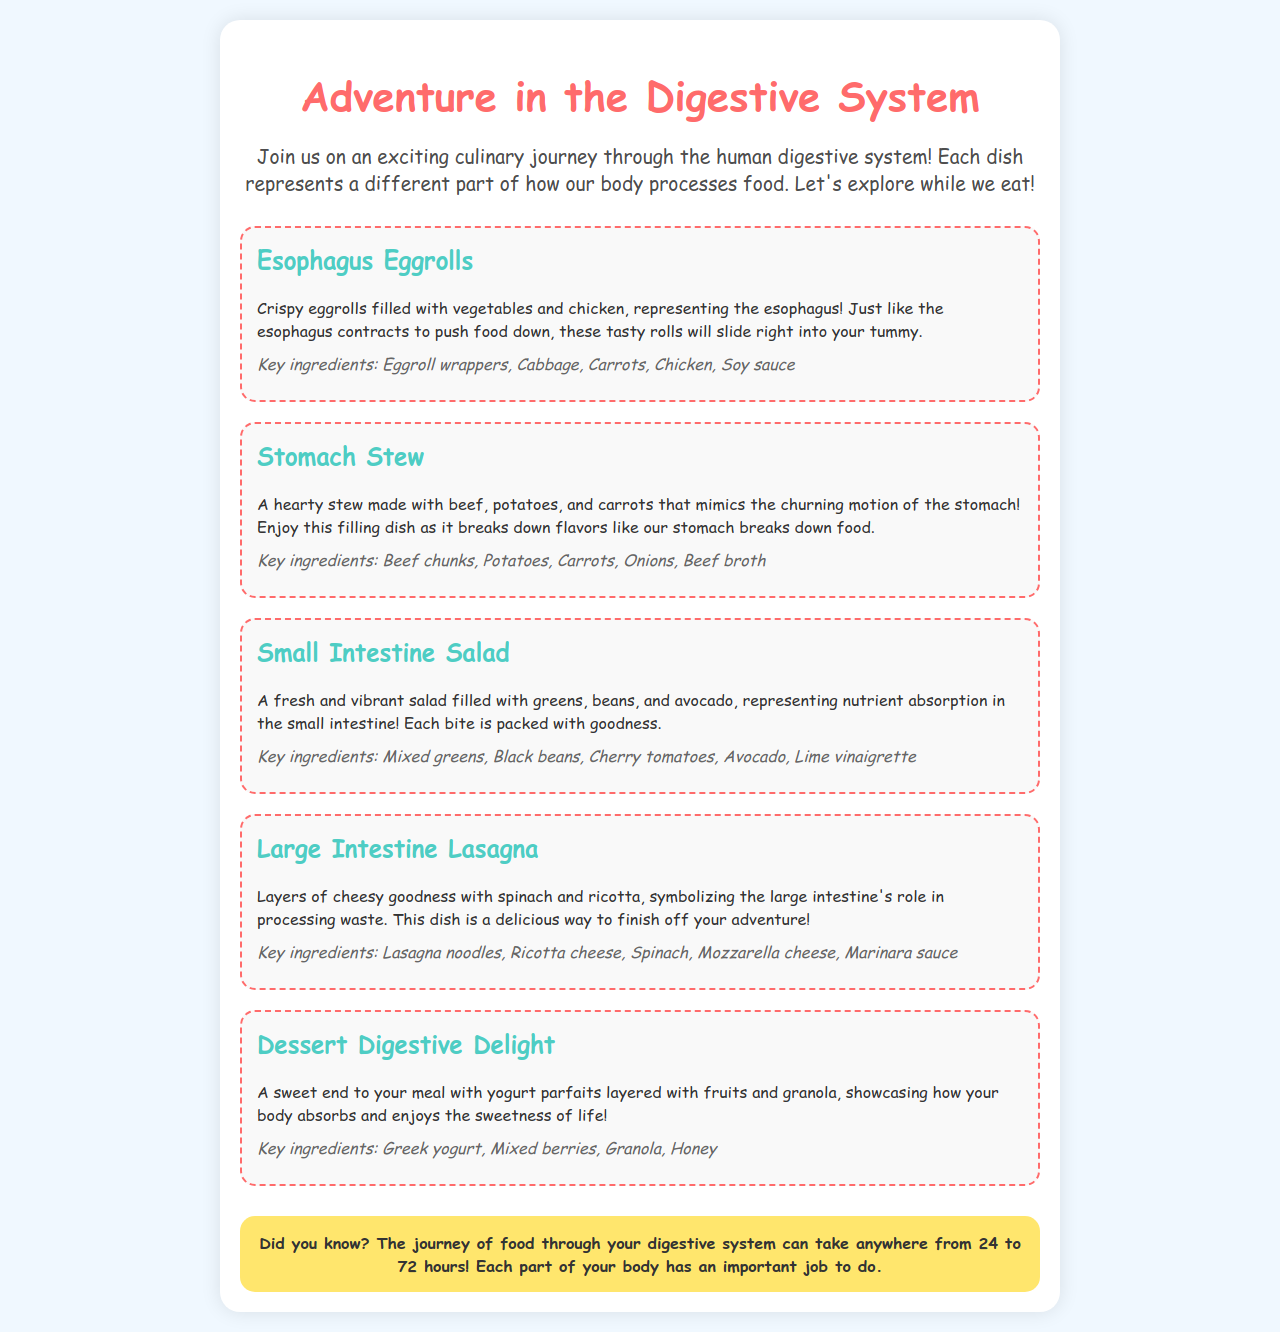What is the name of the dish that represents the esophagus? The dish representing the esophagus is referred to as "Esophagus Eggrolls."
Answer: Esophagus Eggrolls What are the key ingredients of the Stomach Stew? The key ingredients listed for the Stomach Stew include beef chunks, potatoes, carrots, onions, and beef broth.
Answer: Beef chunks, potatoes, carrots, onions, beef broth What dish mimics the nutrient absorption process? The dish that represents nutrient absorption is "Small Intestine Salad."
Answer: Small Intestine Salad How many hours does the journey of food through the digestive system take? The document states that the journey of food through the digestive system can take anywhere from 24 to 72 hours.
Answer: 24 to 72 hours Which dish symbolizes the large intestine's role in processing waste? The dish that symbolizes the role of the large intestine is "Large Intestine Lasagna."
Answer: Large Intestine Lasagna What type of dessert is featured in the menu? The dessert featured in the menu is a yogurt parfait layered with fruits and granola.
Answer: Yogurt parfait What is the color of the title text for the menu? The title text is colored in a shade referred to as "ff6b6b."
Answer: ff6b6b What is the main function represented by the Stomach Stew? The main function represented by the Stomach Stew is the churning motion of the stomach.
Answer: Churning motion of the stomach What type of salad is included in the lunch option? The type of salad included is a fresh and vibrant salad, specifically called "Small Intestine Salad."
Answer: Small Intestine Salad 